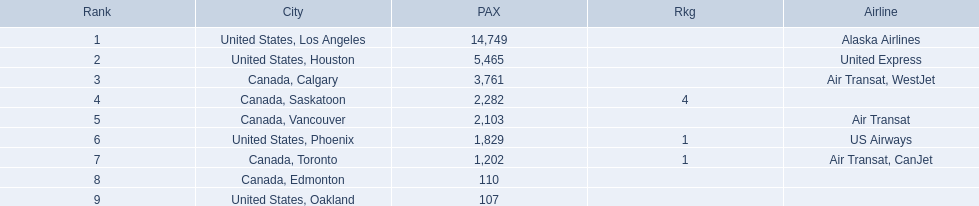What are the cities flown to? United States, Los Angeles, United States, Houston, Canada, Calgary, Canada, Saskatoon, Canada, Vancouver, United States, Phoenix, Canada, Toronto, Canada, Edmonton, United States, Oakland. What number of passengers did pheonix have? 1,829. 